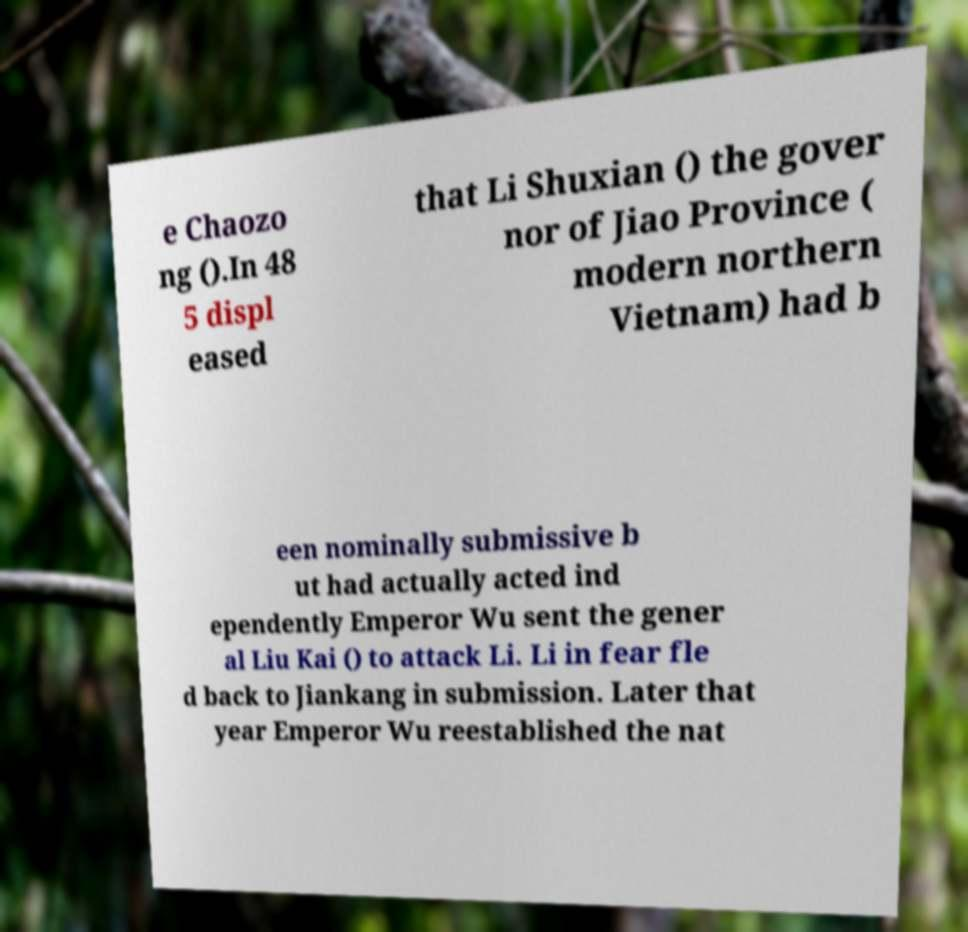What messages or text are displayed in this image? I need them in a readable, typed format. e Chaozo ng ().In 48 5 displ eased that Li Shuxian () the gover nor of Jiao Province ( modern northern Vietnam) had b een nominally submissive b ut had actually acted ind ependently Emperor Wu sent the gener al Liu Kai () to attack Li. Li in fear fle d back to Jiankang in submission. Later that year Emperor Wu reestablished the nat 